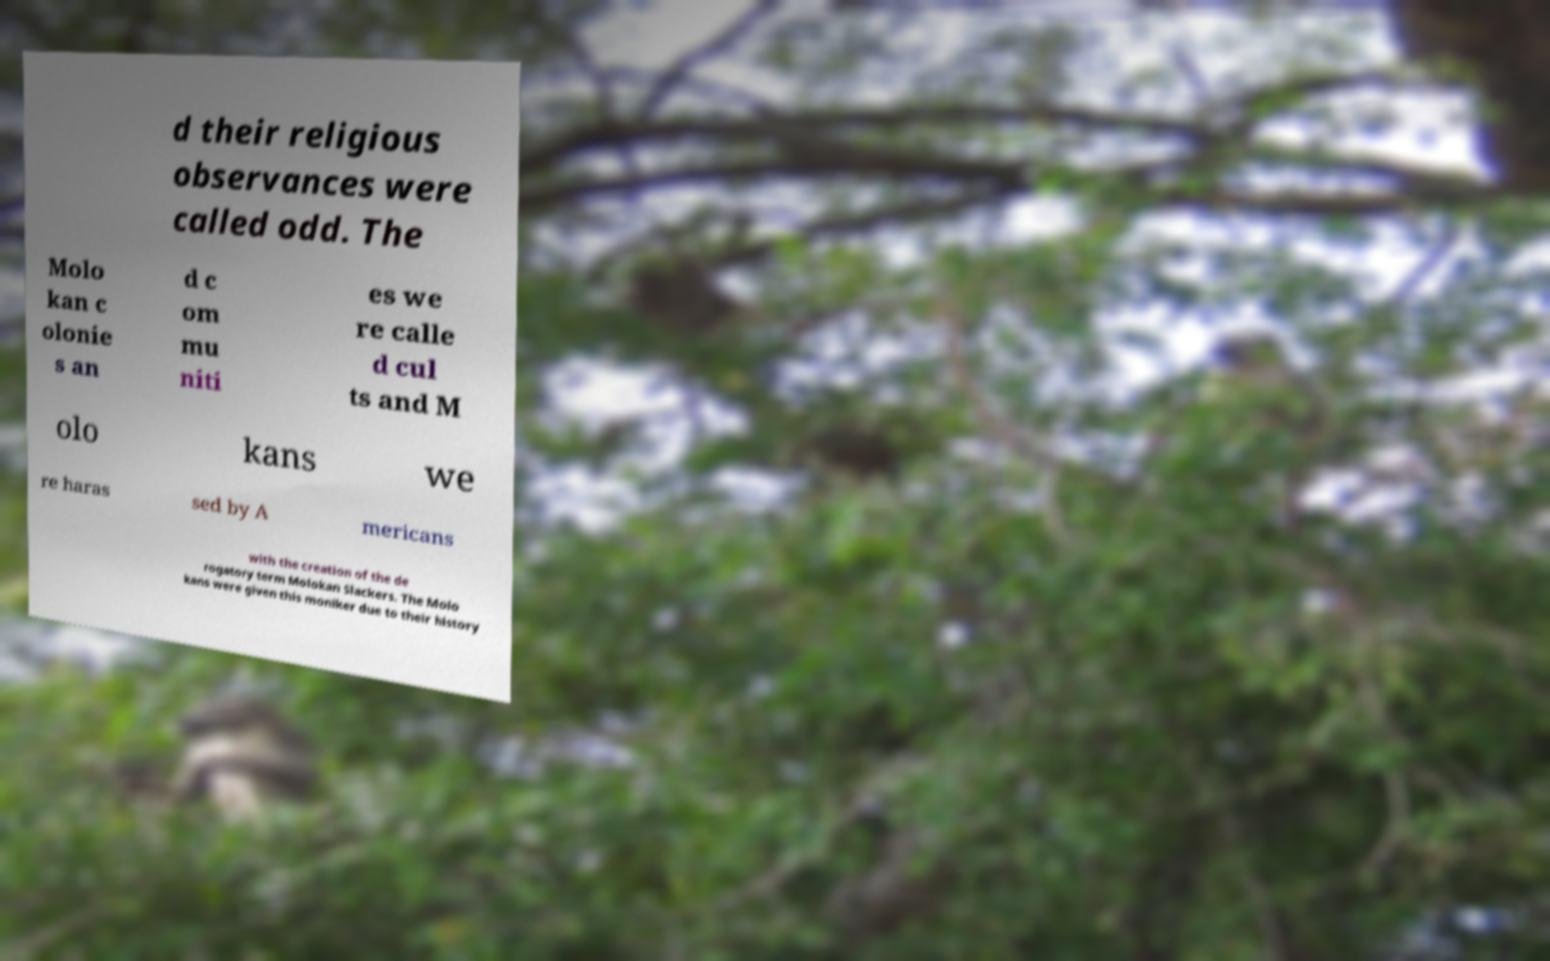Could you assist in decoding the text presented in this image and type it out clearly? d their religious observances were called odd. The Molo kan c olonie s an d c om mu niti es we re calle d cul ts and M olo kans we re haras sed by A mericans with the creation of the de rogatory term Molokan Slackers. The Molo kans were given this moniker due to their history 